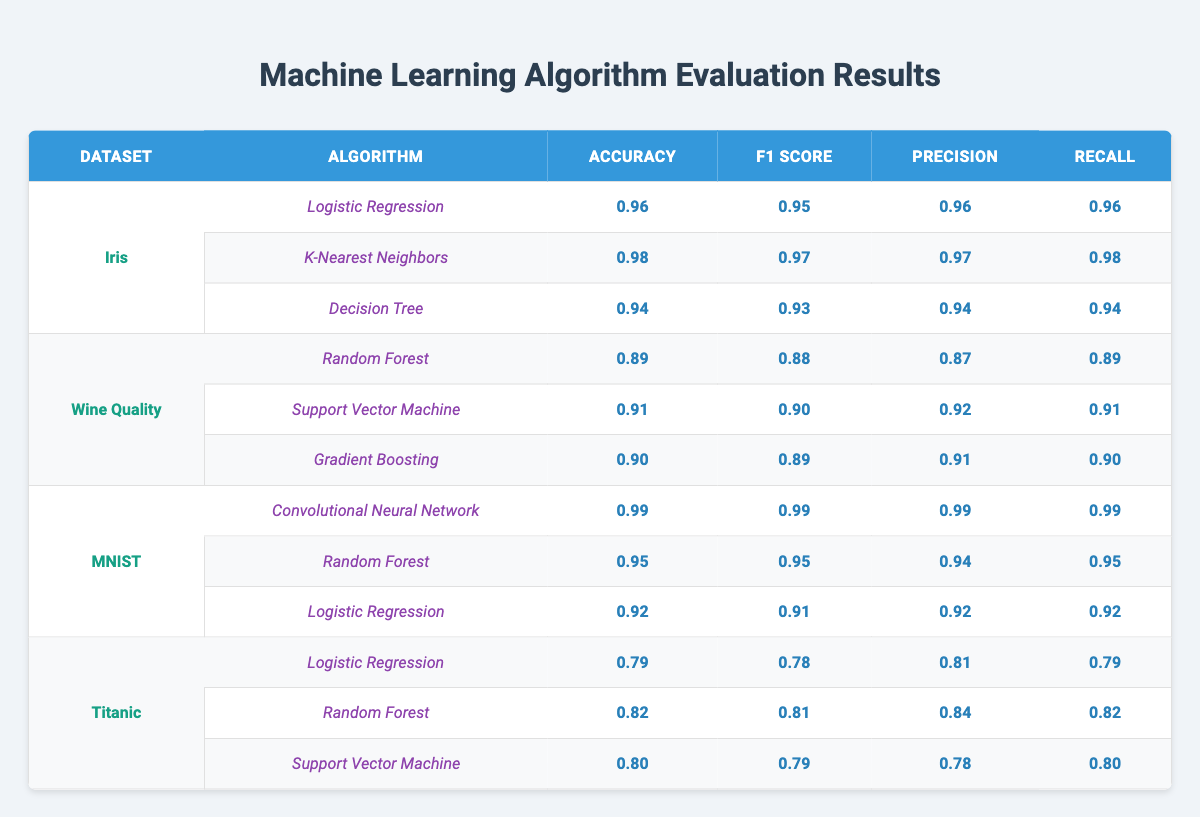What is the highest accuracy achieved on the Iris dataset? From the table, the highest accuracy for the Iris dataset is found under the K-Nearest Neighbors algorithm, which has an accuracy of 0.98.
Answer: 0.98 Which algorithm has the best F1 score on the MNIST dataset? The Convolutional Neural Network algorithm achieves the best F1 score of 0.99 on the MNIST dataset according to the table.
Answer: 0.99 Is the precision for the Gradient Boosting algorithm on the Wine Quality dataset greater than 0.90? In the table, the precision for the Gradient Boosting algorithm is 0.91, which is indeed greater than 0.90.
Answer: Yes Which dataset had the lowest accuracy across all algorithms? Analyzing the accuracies in the table, the Titanic dataset has the lowest accuracy, with the Logistic Regression algorithm achieving 0.79, which is the minimum when compared against other algorithms and datasets.
Answer: Titanic What is the average accuracy of the models on the Wine Quality dataset? The accuracies for the Wine Quality dataset are 0.89 (Random Forest), 0.91 (Support Vector Machine), and 0.90 (Gradient Boosting). Summing these gives 0.89 + 0.91 + 0.90 = 2.70. Dividing by 3 (the number of models) results in an average accuracy of 2.70/3 = 0.90.
Answer: 0.90 Which algorithm performed the worst on the Titanic dataset in terms of recall? Looking at the recall values for the Titanic dataset: Logistic Regression has 0.79, Random Forest has 0.82, and Support Vector Machine has 0.80. Logistic Regression has the lowest recall at 0.79.
Answer: Logistic Regression Is the precision of the K-Nearest Neighbors algorithm on the Iris dataset higher than that of the Random Forest algorithm on the MNIST dataset? The precision for K-Nearest Neighbors on Iris is 0.97, while the precision for Random Forest on MNIST is 0.94. Since 0.97 is greater than 0.94, the statement is true.
Answer: Yes What is the total F1 score for all algorithms on the MNIST dataset? The F1 scores for the MNIST dataset are: 0.99 (CNN), 0.95 (Random Forest), 0.91 (Logistic Regression). Adding these gives 0.99 + 0.95 + 0.91 = 2.85, which is the total F1 score across all algorithms for MNIST.
Answer: 2.85 Which dataset shows the highest recall for its best performing algorithm? By examining the recall values, we find that the Convolutional Neural Network on the MNIST dataset has a recall of 0.99, which is the highest compared to other best performing algorithms across datasets.
Answer: MNIST How does the accuracy of Support Vector Machine on Wine Quality compare to that on Titanic? The accuracy of Support Vector Machine on Wine Quality is 0.91, while its accuracy on Titanic is 0.80. Since 0.91 is higher than 0.80, the comparison indicates the Wine Quality accuracy is greater.
Answer: Wine Quality is greater 